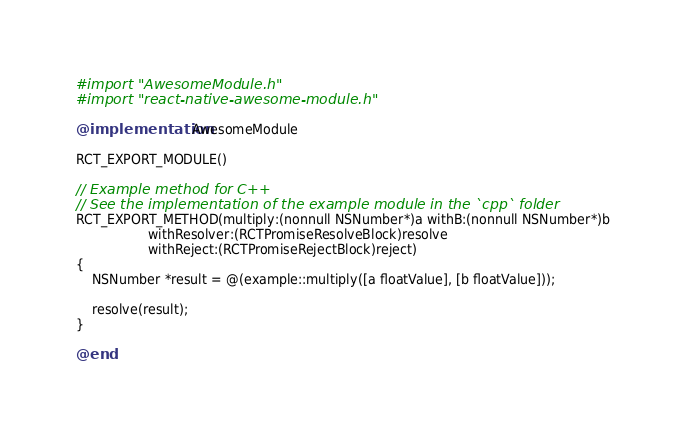Convert code to text. <code><loc_0><loc_0><loc_500><loc_500><_ObjectiveC_>#import "AwesomeModule.h"
#import "react-native-awesome-module.h"

@implementation AwesomeModule

RCT_EXPORT_MODULE()

// Example method for C++
// See the implementation of the example module in the `cpp` folder
RCT_EXPORT_METHOD(multiply:(nonnull NSNumber*)a withB:(nonnull NSNumber*)b
                  withResolver:(RCTPromiseResolveBlock)resolve
                  withReject:(RCTPromiseRejectBlock)reject)
{
    NSNumber *result = @(example::multiply([a floatValue], [b floatValue]));

    resolve(result);
}

@end
</code> 